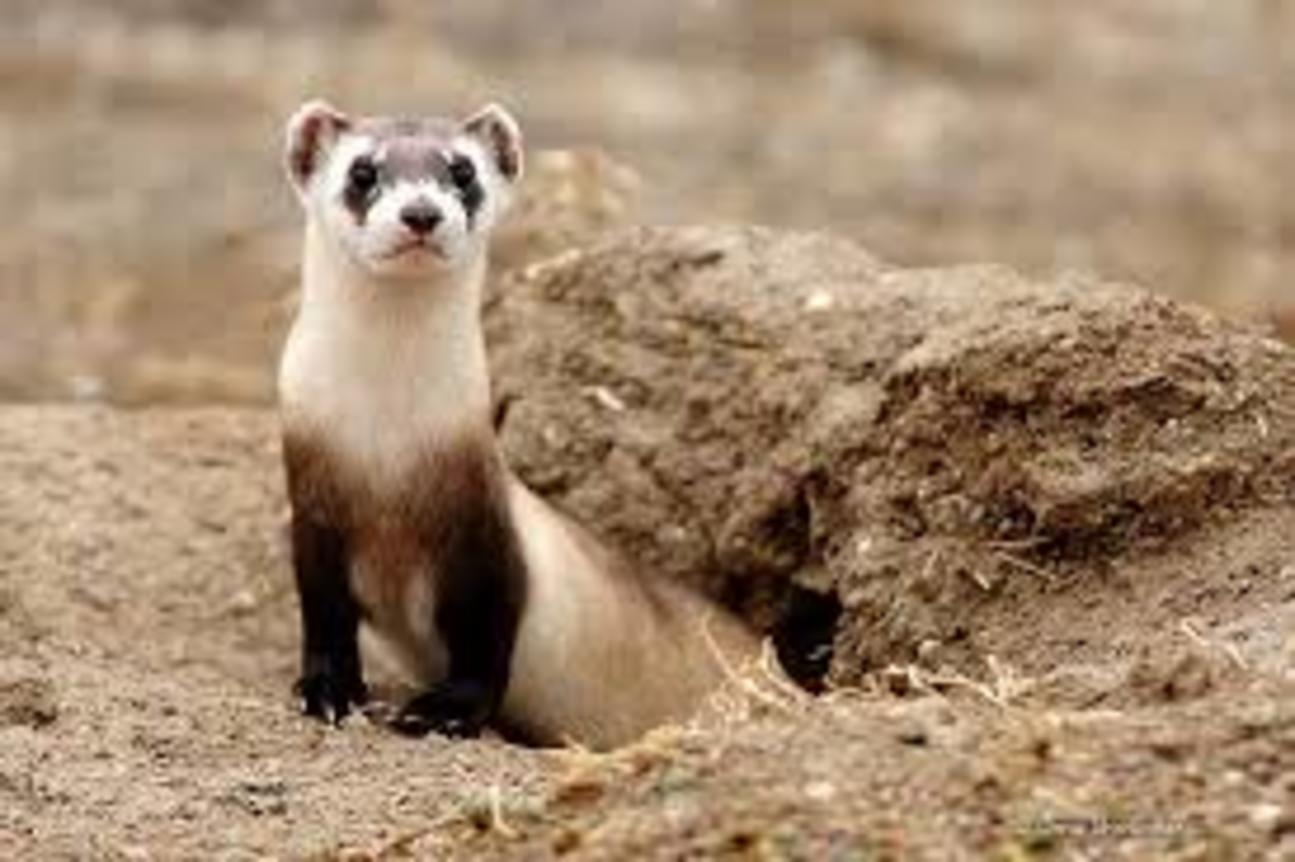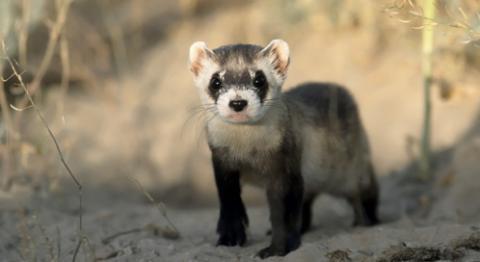The first image is the image on the left, the second image is the image on the right. For the images displayed, is the sentence "There are two ferrets total." factually correct? Answer yes or no. Yes. The first image is the image on the left, the second image is the image on the right. For the images shown, is this caption "There are 3 total ferrets." true? Answer yes or no. No. 